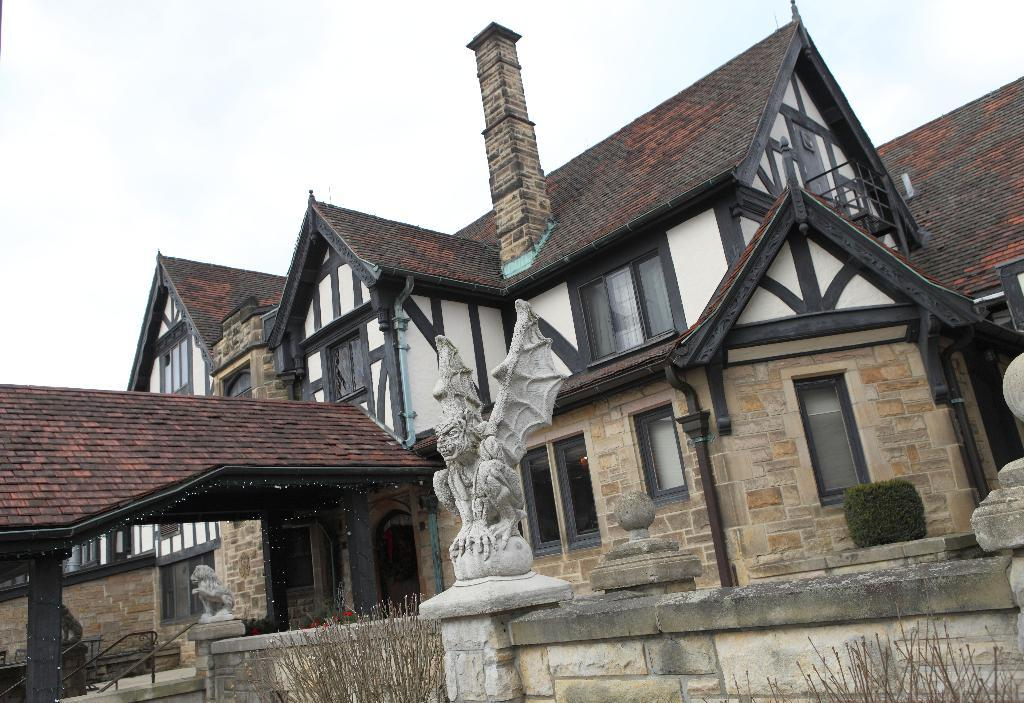What type of structure is visible in the image? There is a building in the image. What decorative elements can be seen in the image? There are statues in the image. What type of vegetation is present in the image? There are plants in the image. What material is used for the rods in the image? There are metal rods in the image. How much money is being exchanged between the statues in the image? There is no money being exchanged between the statues in the image, as they are decorative elements and not involved in any financial transactions. 